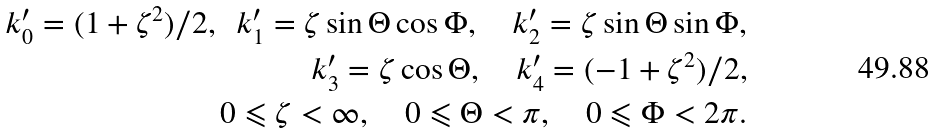Convert formula to latex. <formula><loc_0><loc_0><loc_500><loc_500>k ^ { \prime } _ { 0 } = ( 1 + \zeta ^ { 2 } ) / 2 , \ \ k ^ { \prime } _ { 1 } = \zeta \sin \Theta \cos \Phi , \quad k ^ { \prime } _ { 2 } = \zeta \sin \Theta \sin \Phi , \\ k ^ { \prime } _ { 3 } = \zeta \cos \Theta , \quad k ^ { \prime } _ { 4 } = ( - 1 + \zeta ^ { 2 } ) / 2 , \\ 0 \leqslant \zeta < \infty , \quad 0 \leqslant \Theta < \pi , \quad 0 \leqslant \Phi < 2 \pi .</formula> 